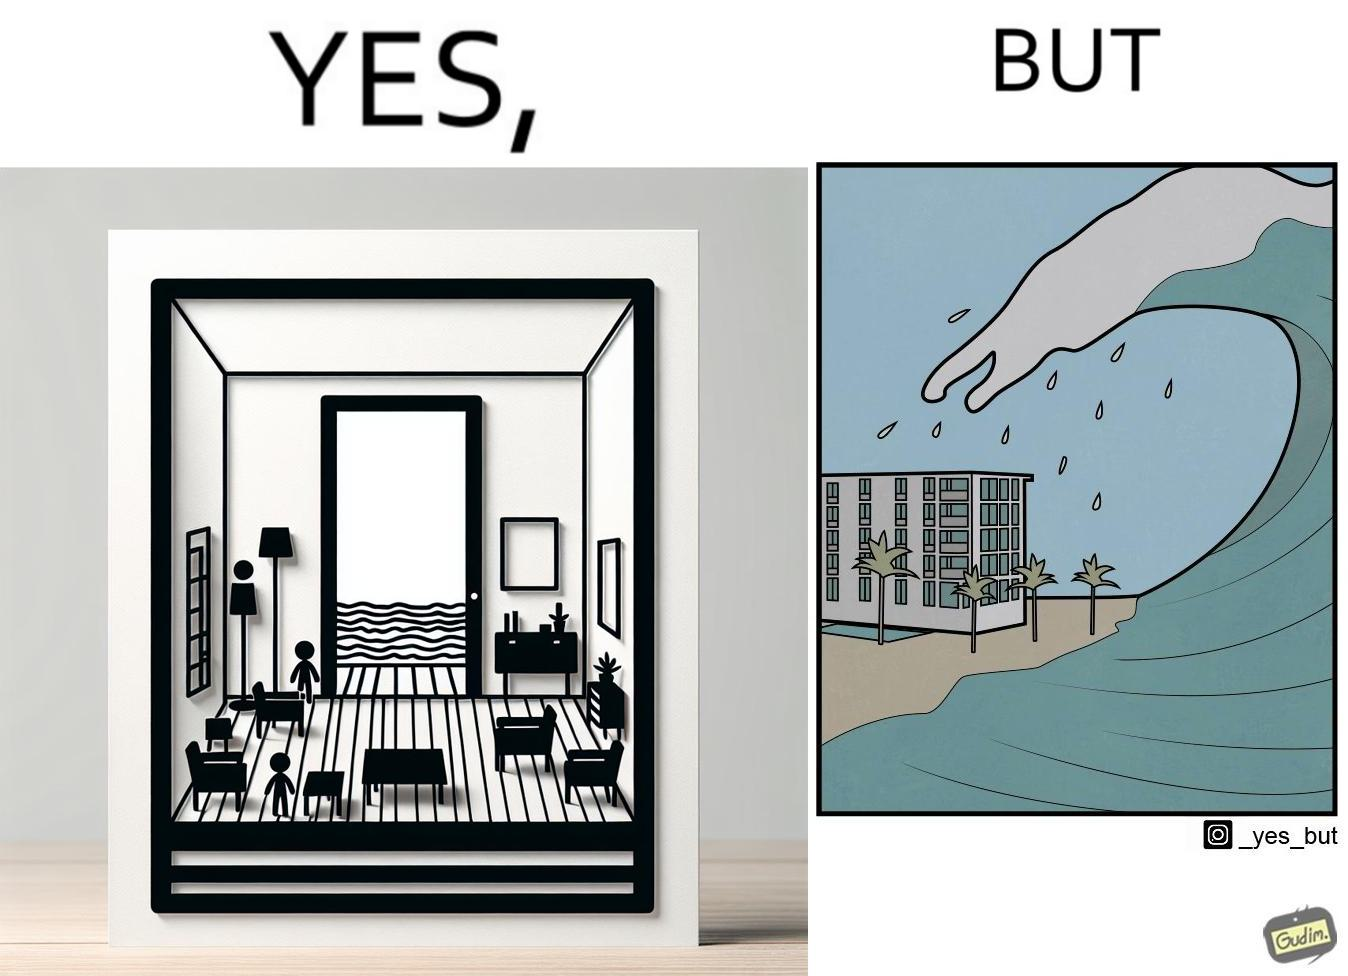Describe what you see in this image. The same sea which gives us a relaxation on a normal day can pose a danger to us sometimes like during a tsunami 